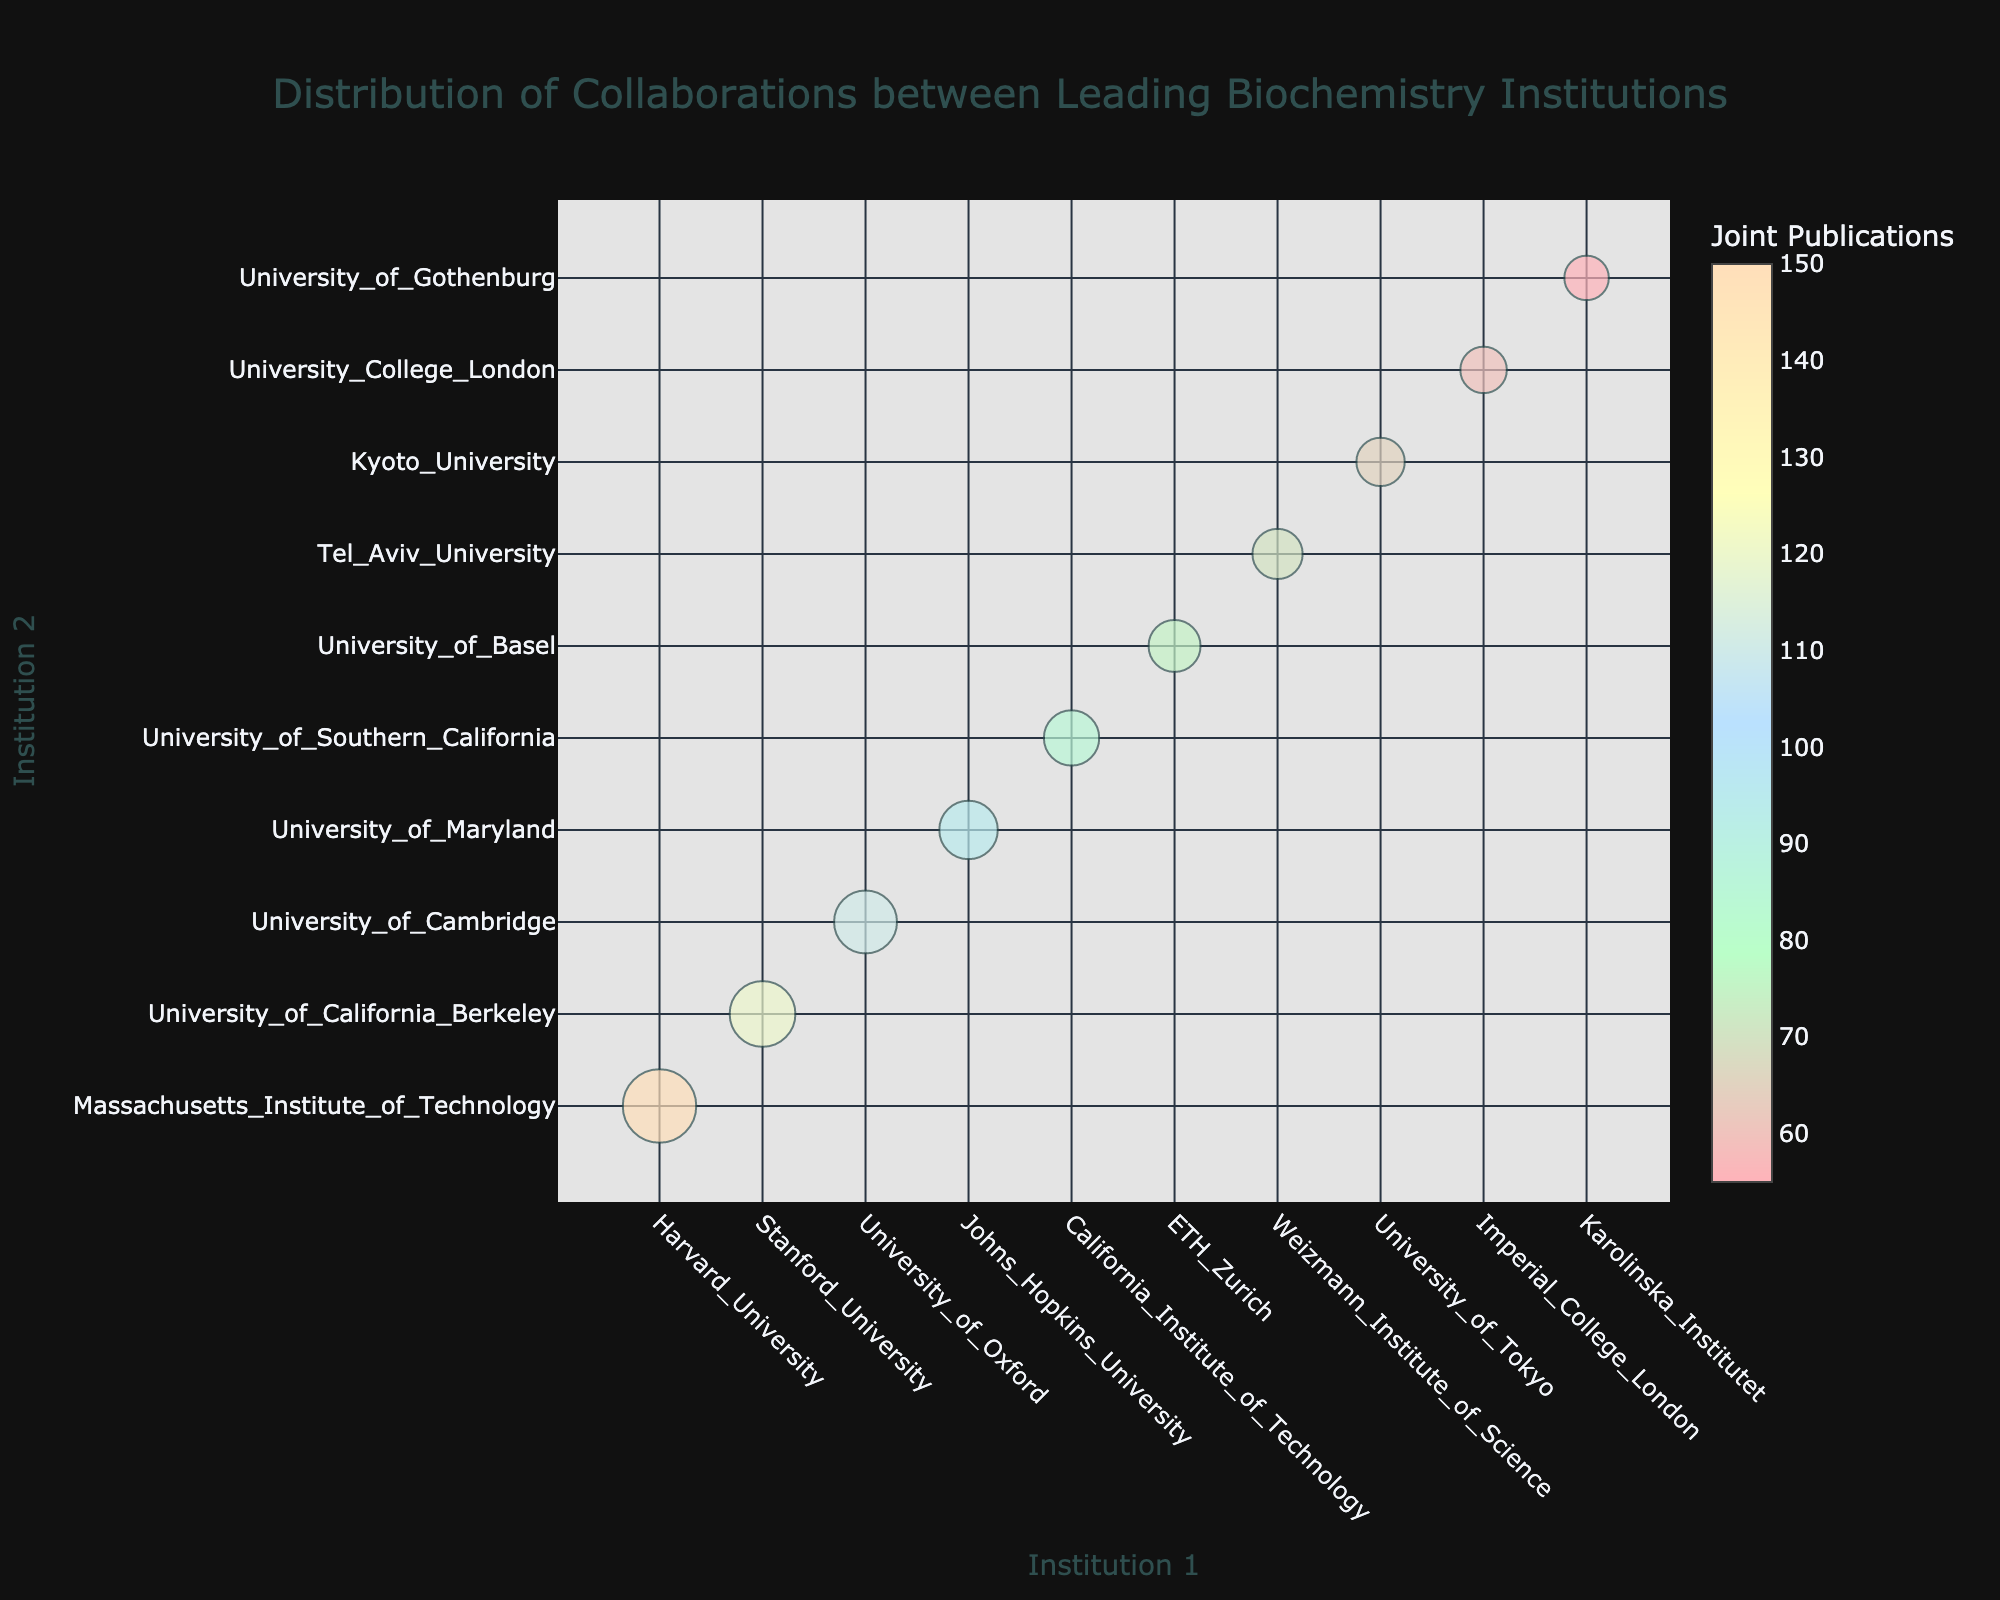what is the title of the figure? The title is usually at the top of the chart. In this case, it reads "Distribution of Collaborations between Leading Biochemistry Institutions".
Answer: Distribution of Collaborations between Leading Biochemistry Institutions How many collaborations have over 100 joint publications? To answer this, locate the bubbles and check their sizes and hover text. There are three bubbles with text indicating over 100 joint publications: Harvard-MIT, Stanford-UC Berkeley, and Oxford-Cambridge.
Answer: 3 Which collaboration has the highest number of joint publications? Find the bubble with the largest size and check the hover text. The largest bubble represents Harvard University and Massachusetts Institute of Technology, with 150 joint publications.
Answer: Harvard University and Massachusetts Institute of Technology What is the smallest number of joint publications represented by bubbles in the chart? Look for the smallest bubbles and check their hover text. The smallest number of joint publications indicated is 55 for Karolinska Institutet and University of Gothenburg.
Answer: 55 Which collaboration is larger in bubble size: Johns Hopkins University - University of Maryland or Weizmann Institute of Science - Tel Aviv University? Compare the sizes of the bubbles and hover text. Johns Hopkins University - University of Maryland has 95 publications, while Weizmann Institute of Science - Tel Aviv University has 70.
Answer: Johns Hopkins University - University of Maryland What is the total number of joint publications for collaborations involving universities in California? Calculate the total by adding the joint publications of Stanford University-UC Berkeley (120) and Caltech-USC (85). So, 120 + 85 = 205.
Answer: 205 How does the collaboration between ETH Zurich and the University of Basel compare in size to the collaboration between the University of Tokyo and Kyoto University? Compare the bubble sizes and hover text. ETH Zurich-University of Basel has 75 publications, and University of Tokyo-Kyoto University has 65.
Answer: ETH Zurich and University of Basel What color represents the number of joint publications on the color scale in the figure? The bubble colors range from pinkish to light blue as indicated on the color scale and the color bar. Maximum values appear darker while lower values are lighter.
Answer: Pinkish to Light Blue Which international collaboration has the highest number of joint publications? Scan the bubbles and their hover texts for international pairings. The highest number of 110 publications is from the University of Oxford and the University of Cambridge.
Answer: University of Oxford and University of Cambridge How many European collaborations are present in this chart? Count the bubbles involving European institutions: University of Oxford-Cambridge, ETH Zurich-Basel, Imperial College London-UCL, and Karolinska Institutet-Gothenburg are from Europe. There are 4 collaborations.
Answer: 4 